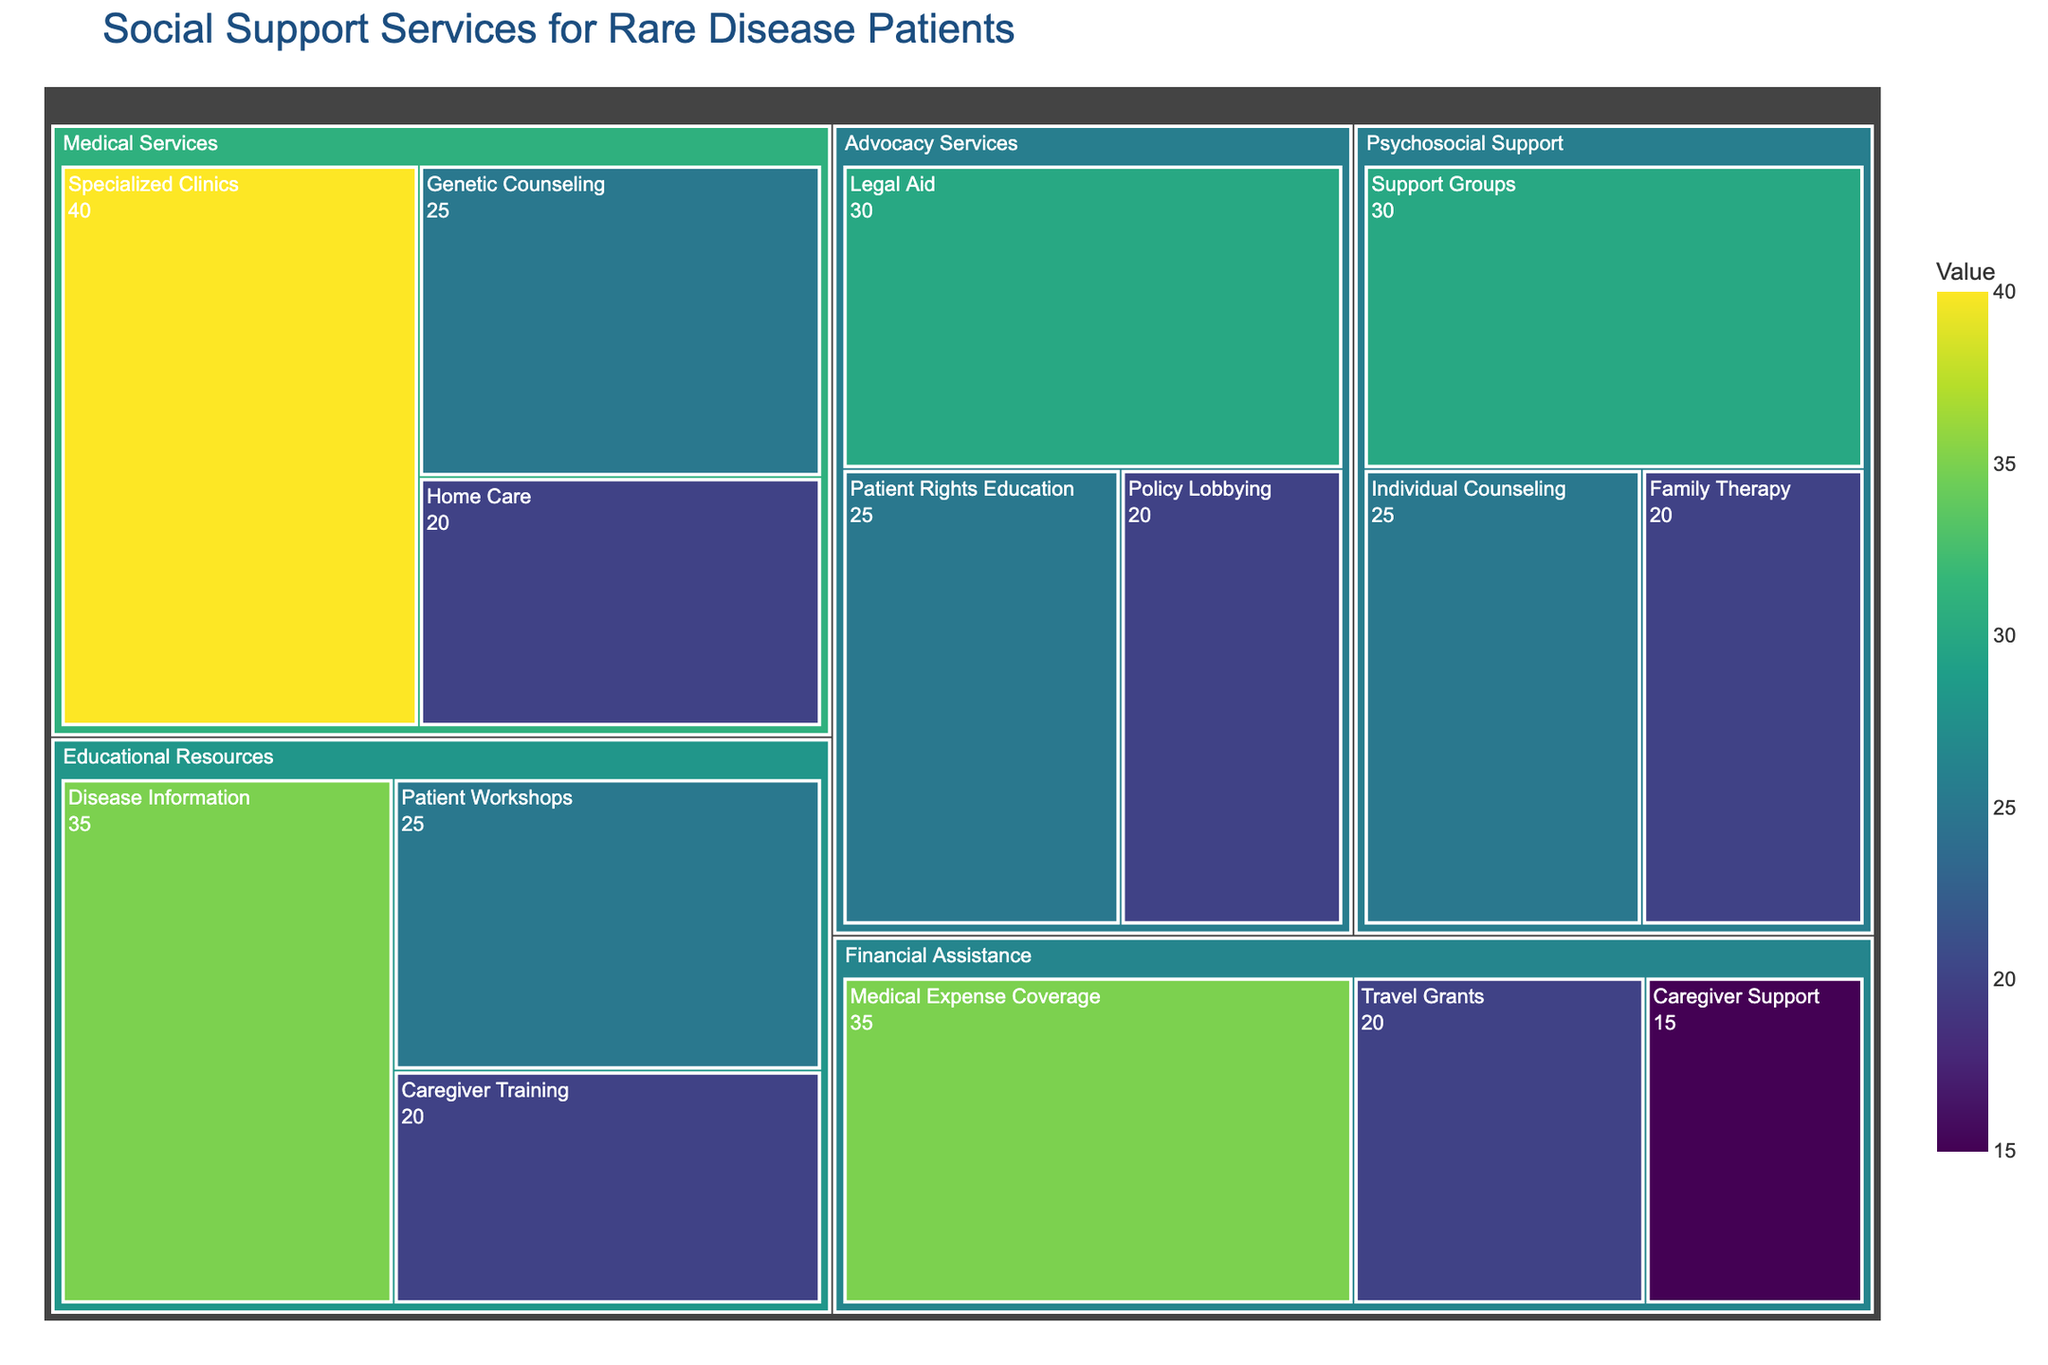What is the title of the treemap? The title is typically located at the top of the treemap and provides a description of what the figure is about.
Answer: Social Support Services for Rare Disease Patients Which category has the highest value in the treemap? To determine this, look for the largest block in the treemap. Medical Services has a total value of 85 (40 + 25 + 20), while Financial Assistance totals 70 (35 + 20 + 15), making Medical Services the highest.
Answer: Medical Services How much value does 'Individual Counseling' under 'Psychosocial Support' hold? Locate the 'Psychosocial Support' category in the treemap and identify the 'Individual Counseling' subcategory to find its value.
Answer: 25 What is the combined value of 'Disease Information' and 'Patient Workshops' under 'Educational Resources'? Add the values of 'Disease Information' (35) and 'Patient Workshops' (25). 35 + 25 = 60.
Answer: 60 Which subcategory under 'Financial Assistance' has the lowest value? Compare the values of all subcategories under 'Financial Assistance'. 'Caregiver Support' has 15, which is the lowest among 'Medical Expense Coverage' (35) and 'Travel Grants' (20).
Answer: Caregiver Support How does 'Genetic Counseling' compare to 'Home Care' in terms of value under 'Medical Services'? Both 'Genetic Counseling' at 25 and 'Home Care' at 20 fall under 'Medical Services'. 25 (Genetic Counseling) is greater than 20 (Home Care).
Answer: Genetic Counseling is greater What is the total value for the 'Psychosocial Support' category? Add the values of all subcategories under 'Psychosocial Support': 'Support Groups' (30), 'Individual Counseling' (25), and 'Family Therapy' (20). 30 + 25 + 20 = 75.
Answer: 75 Which category has a subcategory named 'Policy Lobbying', and what is its value? Locate 'Policy Lobbying' in the treemap and identify its corresponding category, which is 'Advocacy Services' with a value of 20.
Answer: Advocacy Services, 20 What is the difference in value between 'Legal Aid' and 'Caregiver Support'? 'Legal Aid' under 'Advocacy Services' has a value of 30, and 'Caregiver Support' under 'Financial Assistance' has 15. The difference is 30 - 15 = 15.
Answer: 15 What is the average value of all subcategories under 'Medical Services'? Calculate by adding the values of 'Specialized Clinics' (40), 'Genetic Counseling' (25), and 'Home Care' (20), then divide by the number of subcategories (3). (40 + 25 + 20) / 3 = 28.33
Answer: 28.33 